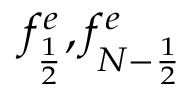<formula> <loc_0><loc_0><loc_500><loc_500>f _ { \frac { 1 } { 2 } } ^ { e } , f _ { { N - \frac { 1 } { 2 } } } ^ { e }</formula> 